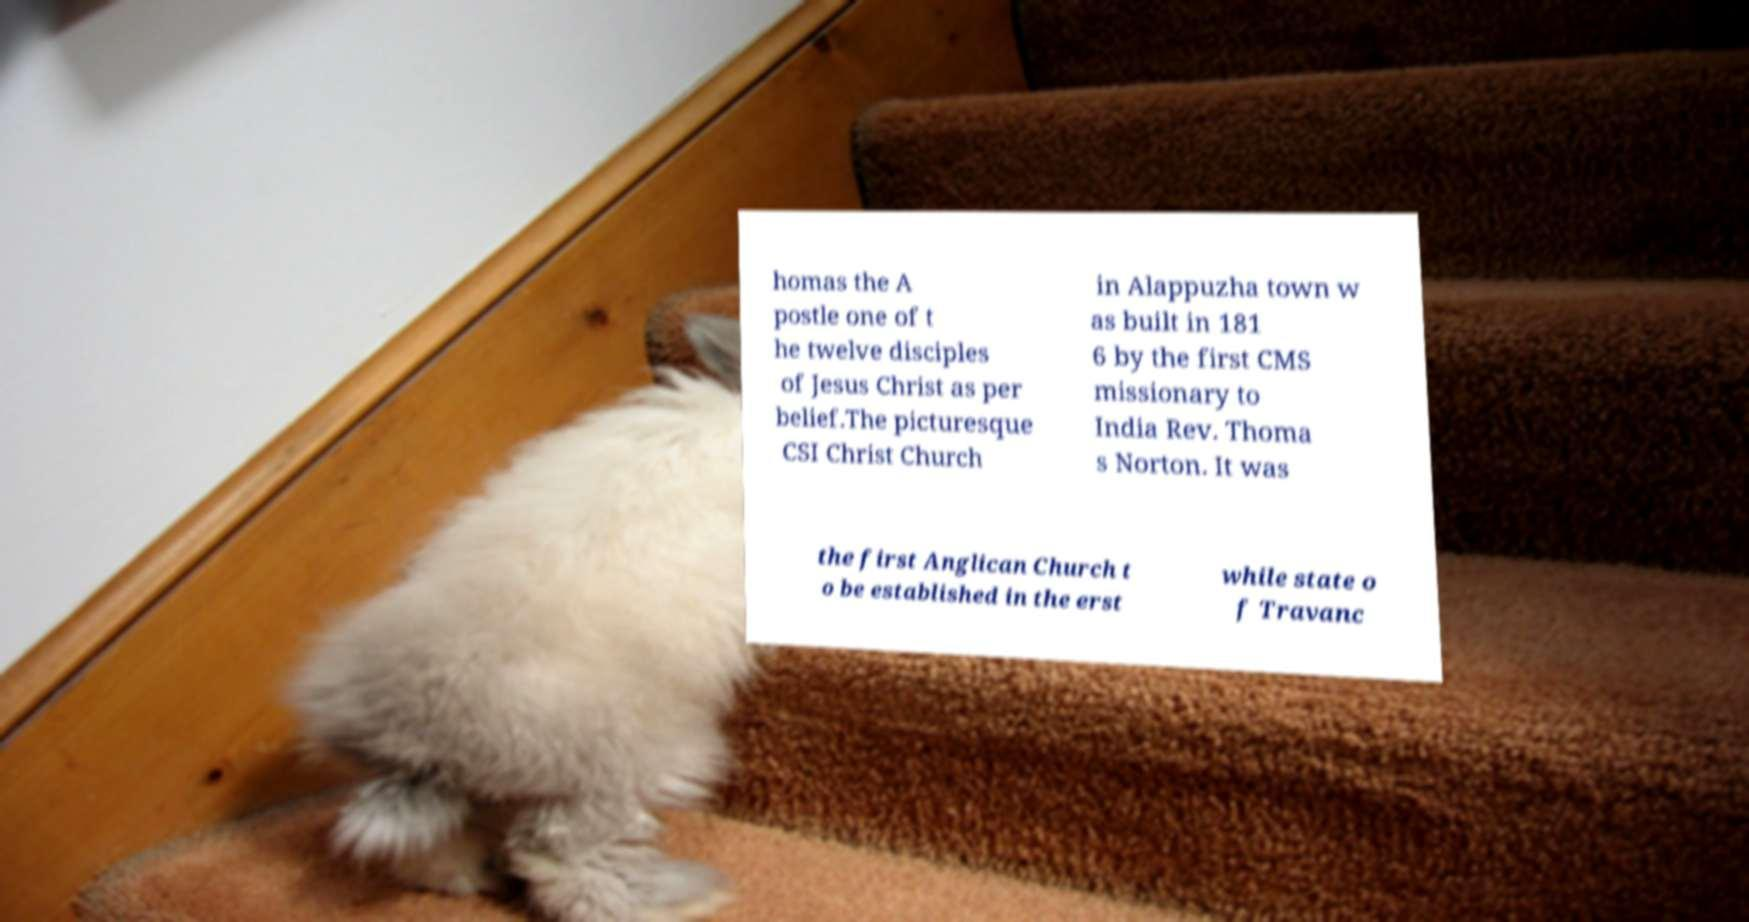I need the written content from this picture converted into text. Can you do that? homas the A postle one of t he twelve disciples of Jesus Christ as per belief.The picturesque CSI Christ Church in Alappuzha town w as built in 181 6 by the first CMS missionary to India Rev. Thoma s Norton. It was the first Anglican Church t o be established in the erst while state o f Travanc 